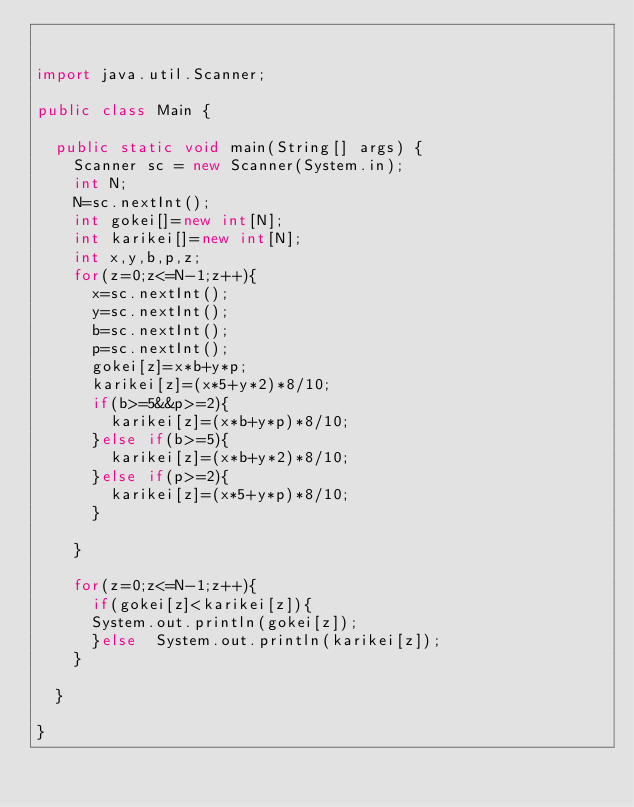Convert code to text. <code><loc_0><loc_0><loc_500><loc_500><_Java_>

import java.util.Scanner;

public class Main {
	
	public static void main(String[] args) {
		Scanner sc = new Scanner(System.in);
		int N;
		N=sc.nextInt();
		int gokei[]=new int[N];
		int karikei[]=new int[N];
		int x,y,b,p,z;
		for(z=0;z<=N-1;z++){
			x=sc.nextInt();
			y=sc.nextInt();
			b=sc.nextInt();
			p=sc.nextInt();
			gokei[z]=x*b+y*p;
			karikei[z]=(x*5+y*2)*8/10;
			if(b>=5&&p>=2){
				karikei[z]=(x*b+y*p)*8/10;
			}else if(b>=5){
				karikei[z]=(x*b+y*2)*8/10;
			}else if(p>=2){
				karikei[z]=(x*5+y*p)*8/10;
			}
			
		}

		for(z=0;z<=N-1;z++){
			if(gokei[z]<karikei[z]){
			System.out.println(gokei[z]);
			}else  System.out.println(karikei[z]);
		}

	}

}</code> 